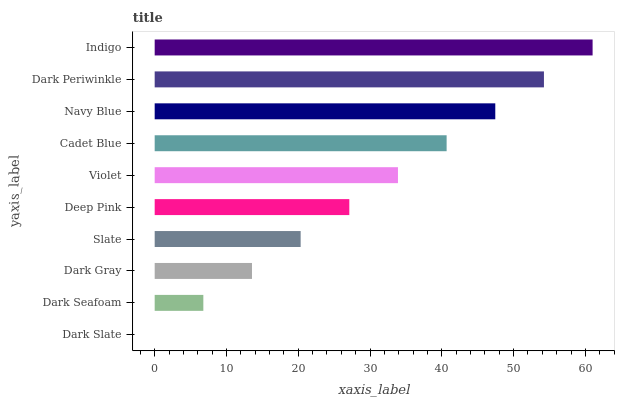Is Dark Slate the minimum?
Answer yes or no. Yes. Is Indigo the maximum?
Answer yes or no. Yes. Is Dark Seafoam the minimum?
Answer yes or no. No. Is Dark Seafoam the maximum?
Answer yes or no. No. Is Dark Seafoam greater than Dark Slate?
Answer yes or no. Yes. Is Dark Slate less than Dark Seafoam?
Answer yes or no. Yes. Is Dark Slate greater than Dark Seafoam?
Answer yes or no. No. Is Dark Seafoam less than Dark Slate?
Answer yes or no. No. Is Violet the high median?
Answer yes or no. Yes. Is Deep Pink the low median?
Answer yes or no. Yes. Is Dark Periwinkle the high median?
Answer yes or no. No. Is Dark Seafoam the low median?
Answer yes or no. No. 